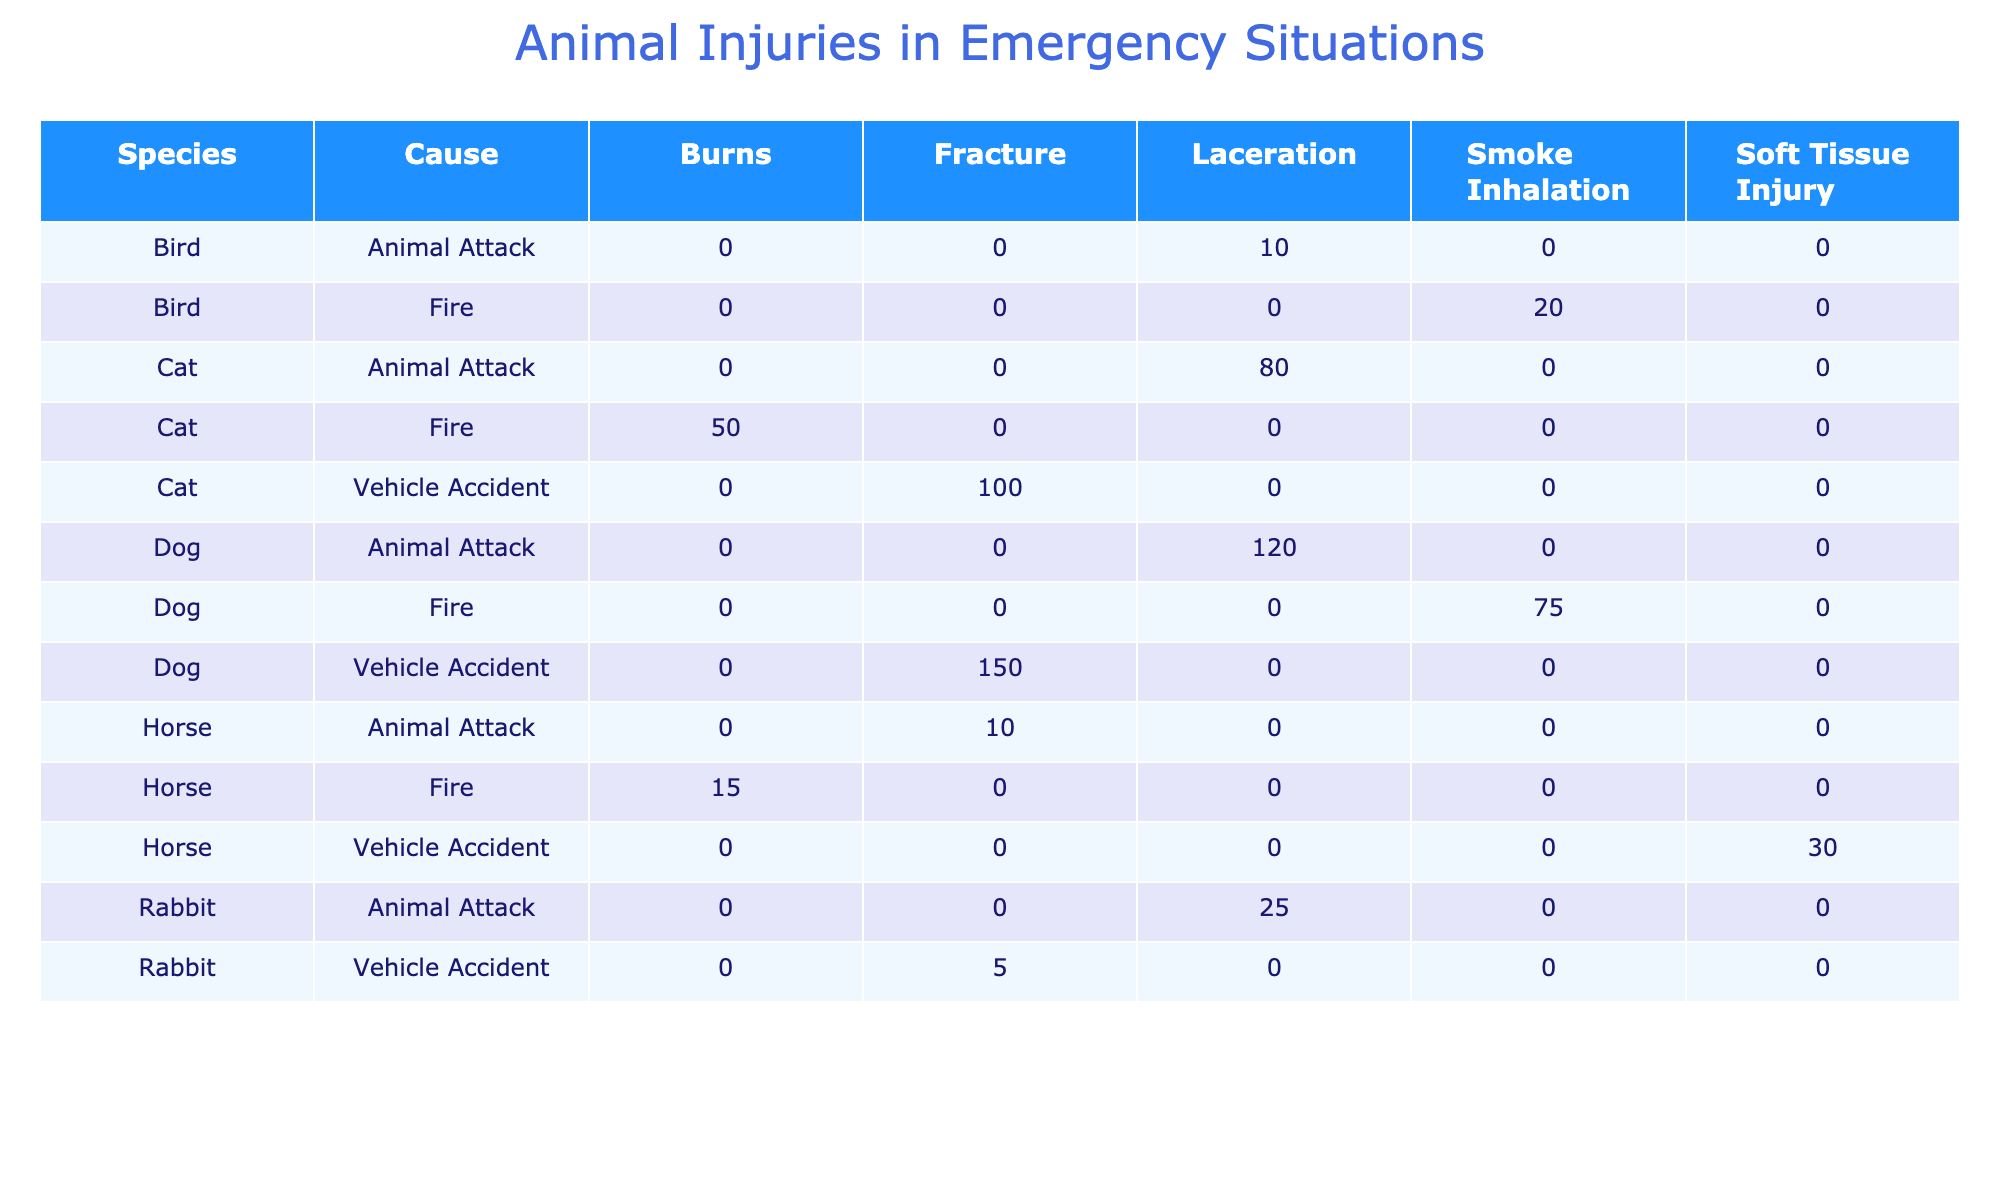What type of injury is most common for dogs involved in vehicle accidents? The table shows that dogs involved in vehicle accidents primarily sustain fractures, as indicated by the entry for "Dog" and "Vehicle Accident" with "Fracture," which has 150 cases.
Answer: Fracture How many cases of burns are recorded for horses due to fire? The table displays that there are 15 cases of burns for horses related to fire, as shown in the row for "Horse" and "Fire" with "Burns."
Answer: 15 Is smoke inhalation a cause of injury reported for birds? Yes, smoke inhalation is listed as an injury type for birds in the case of fire, with 20 recorded cases under "Bird" and "Fire" with "Smoke Inhalation."
Answer: Yes Which species has the highest total number of injuries from vehicle accidents? To determine this, we sum the number of cases of injuries from vehicle accidents for each species: Dogs (150), Cats (100), Horses (30), and Rabbits (5). The total for dogs is the highest at 150 cases.
Answer: Dogs What is the total number of laceration cases across all species due to animal attacks? We look for the injury type "Laceration" under the "Animal Attack" cause for each species. The total is calculated as: 120 (Dogs) + 80 (Cats) + 25 (Rabbits) + 10 (Birds) = 235 cases of lacerations.
Answer: 235 How many more cases of smoke inhalation are reported for dogs than for birds? The table shows 75 cases of smoke inhalation for dogs under "Fire" and 20 cases for birds under "Fire." The difference is 75 - 20 = 55 cases, indicating dogs have 55 more cases of smoke inhalation than birds.
Answer: 55 Does any species have injuries from both vehicle accidents and animal attacks? Yes, both dogs and cats are recorded with injuries from both vehicle accidents and animal attacks, which verifies that these species are involved in both situations.
Answer: Yes What is the average number of cases of fractures for all species when involved in vehicle accidents? We sum the number of fracture cases from the vehicle accidents: 150 (Dogs) + 100 (Cats) + 30 (Horses) + 5 (Rabbits) = 285 total cases. Dividing by the number of species (4) gives us an average of 285 / 4 = 71.25.
Answer: 71.25 